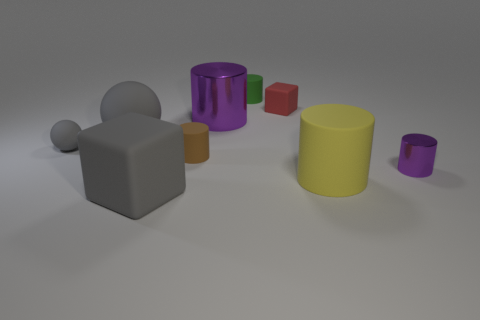What emotions or ideas could this arrangement of shapes be trying to convey? The arrangement and variety of shapes might suggest diversity and uniqueness. The scattered placement could evoke a sense of randomness or freedom, and the color differences among the shapes may signify individuality or creativity. 